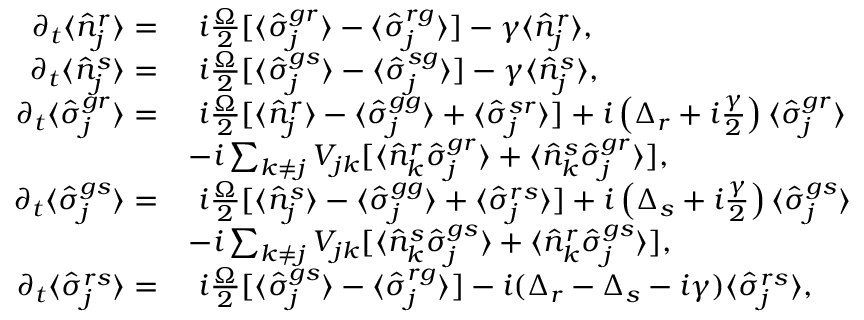Convert formula to latex. <formula><loc_0><loc_0><loc_500><loc_500>\begin{array} { r l } { \partial _ { t } \langle \hat { n } _ { j } ^ { r } \rangle = } & { \ i \frac { \Omega } { 2 } [ \langle \hat { \sigma } _ { j } ^ { g r } \rangle - \langle \hat { \sigma } _ { j } ^ { r g } \rangle ] - \gamma \langle \hat { n } _ { j } ^ { r } \rangle , } \\ { \partial _ { t } \langle \hat { n } _ { j } ^ { s } \rangle = } & { \ i \frac { \Omega } { 2 } [ \langle \hat { \sigma } _ { j } ^ { g s } \rangle - \langle \hat { \sigma } _ { j } ^ { s g } \rangle ] - \gamma \langle \hat { n } _ { j } ^ { s } \rangle , } \\ { \partial _ { t } \langle \hat { \sigma } _ { j } ^ { g r } \rangle = } & { \ i \frac { \Omega } { 2 } [ \langle \hat { n } _ { j } ^ { r } \rangle - \langle \hat { \sigma } _ { j } ^ { g g } \rangle + \langle \hat { \sigma } _ { j } ^ { s r } \rangle ] + i \left ( \Delta _ { r } + i \frac { \gamma } { 2 } \right ) \langle \hat { \sigma } _ { j } ^ { g r } \rangle } \\ & { - i \sum _ { k \neq j } V _ { j k } [ \langle \hat { n } _ { k } ^ { r } \hat { \sigma } _ { j } ^ { g r } \rangle + \langle \hat { n } _ { k } ^ { s } \hat { \sigma } _ { j } ^ { g r } \rangle ] , } \\ { \partial _ { t } \langle \hat { \sigma } _ { j } ^ { g s } \rangle = } & { \ i \frac { \Omega } { 2 } [ \langle \hat { n } _ { j } ^ { s } \rangle - \langle \hat { \sigma } _ { j } ^ { g g } \rangle + \langle \hat { \sigma } _ { j } ^ { r s } \rangle ] + i \left ( \Delta _ { s } + i \frac { \gamma } { 2 } \right ) \langle \hat { \sigma } _ { j } ^ { g s } \rangle } \\ & { - i \sum _ { k \neq j } V _ { j k } [ \langle \hat { n } _ { k } ^ { s } \hat { \sigma } _ { j } ^ { g s } \rangle + \langle \hat { n } _ { k } ^ { r } \hat { \sigma } _ { j } ^ { g s } \rangle ] , } \\ { \partial _ { t } \langle \hat { \sigma } _ { j } ^ { r s } \rangle = } & { \ i \frac { \Omega } { 2 } [ \langle \hat { \sigma } _ { j } ^ { g s } \rangle - \langle \hat { \sigma } _ { j } ^ { r g } \rangle ] - i ( \Delta _ { r } - \Delta _ { s } - i { \gamma } ) \langle \hat { \sigma } _ { j } ^ { r s } \rangle , } \end{array}</formula> 